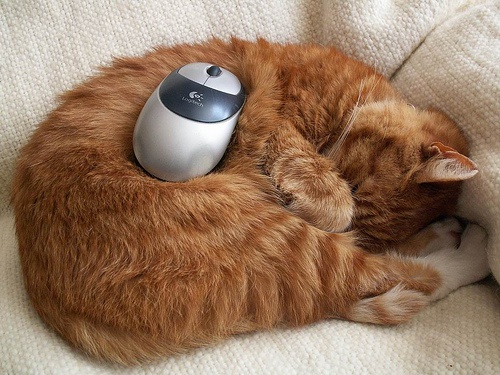Describe the objects in this image and their specific colors. I can see cat in darkgray, maroon, brown, and gray tones and mouse in darkgray, gray, lightgray, and black tones in this image. 